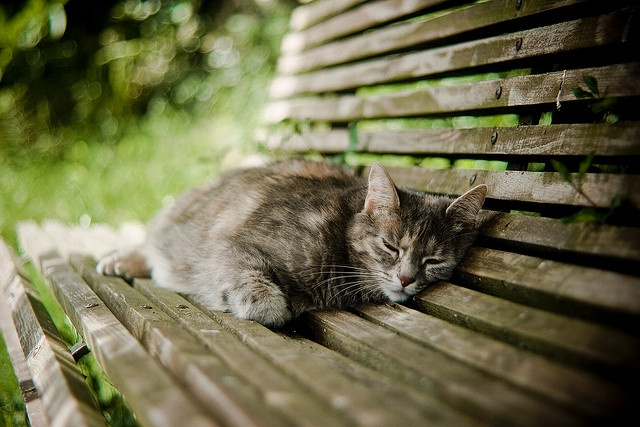Describe the objects in this image and their specific colors. I can see bench in black, olive, darkgray, and darkgreen tones and cat in black, darkgray, and gray tones in this image. 